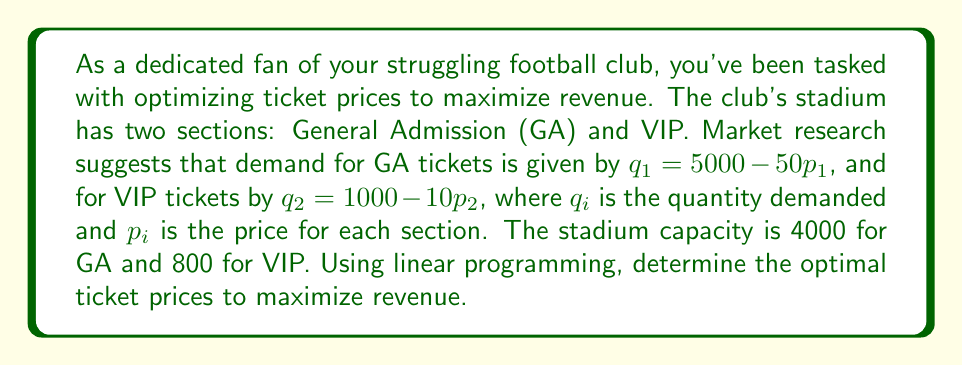Can you answer this question? Let's approach this step-by-step using linear programming:

1) Define variables:
   $p_1$ = price of GA tickets
   $p_2$ = price of VIP tickets

2) Objective function (maximize revenue):
   $R = p_1q_1 + p_2q_2$
   $R = p_1(5000 - 50p_1) + p_2(1000 - 10p_2)$
   $R = 5000p_1 - 50p_1^2 + 1000p_2 - 10p_2^2$

3) Constraints:
   Capacity: $q_1 \leq 4000$ and $q_2 \leq 800$
   Non-negative demand: $q_1 \geq 0$ and $q_2 \geq 0$

4) Rewrite constraints in terms of prices:
   $5000 - 50p_1 \leq 4000$ $\implies$ $p_1 \geq 20$
   $1000 - 10p_2 \leq 800$ $\implies$ $p_2 \geq 20$
   $5000 - 50p_1 \geq 0$ $\implies$ $p_1 \leq 100$
   $1000 - 10p_2 \geq 0$ $\implies$ $p_2 \leq 100$

5) To maximize R, we need to find the maximum of $5000p_1 - 50p_1^2 + 1000p_2 - 10p_2^2$

6) Take partial derivatives and set to zero:
   $\frac{\partial R}{\partial p_1} = 5000 - 100p_1 = 0$ $\implies$ $p_1 = 50$
   $\frac{\partial R}{\partial p_2} = 1000 - 20p_2 = 0$ $\implies$ $p_2 = 50$

7) Check if this solution satisfies constraints:
   $20 \leq 50 \leq 100$ for both $p_1$ and $p_2$, so it does.

8) Calculate maximum revenue:
   $R = 50(5000 - 50(50)) + 50(1000 - 10(50))$
   $R = 50(2500) + 50(500) = 125000 + 25000 = 150000$
Answer: $p_1 = \$50$, $p_2 = \$50$, Maximum Revenue = $\$150,000$ 